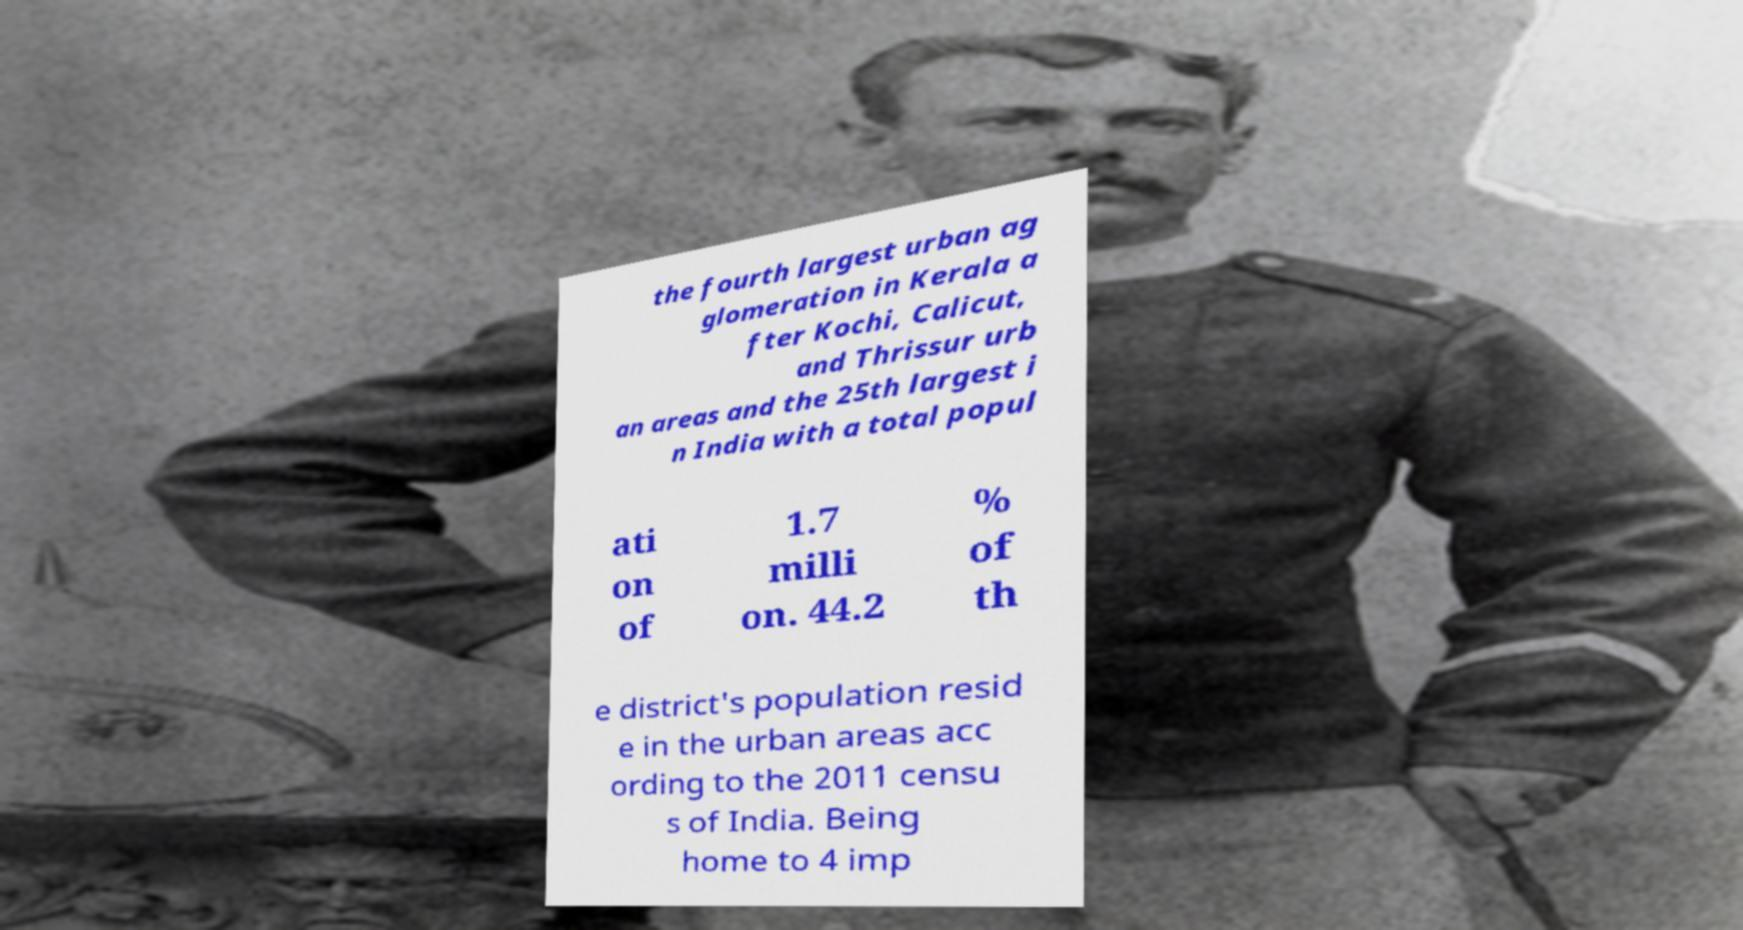I need the written content from this picture converted into text. Can you do that? the fourth largest urban ag glomeration in Kerala a fter Kochi, Calicut, and Thrissur urb an areas and the 25th largest i n India with a total popul ati on of 1.7 milli on. 44.2 % of th e district's population resid e in the urban areas acc ording to the 2011 censu s of India. Being home to 4 imp 